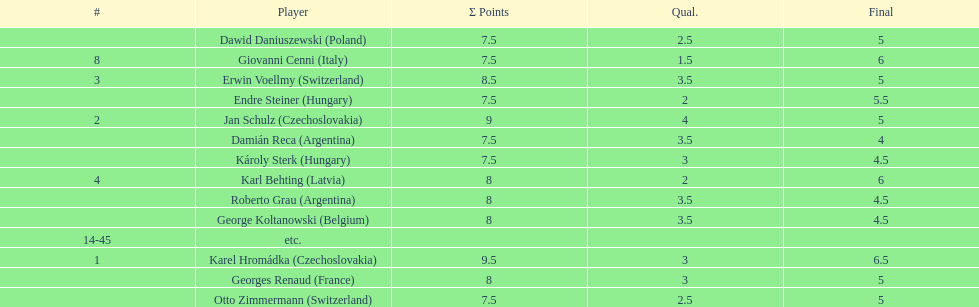How many countries had more than one player in the consolation cup? 4. 